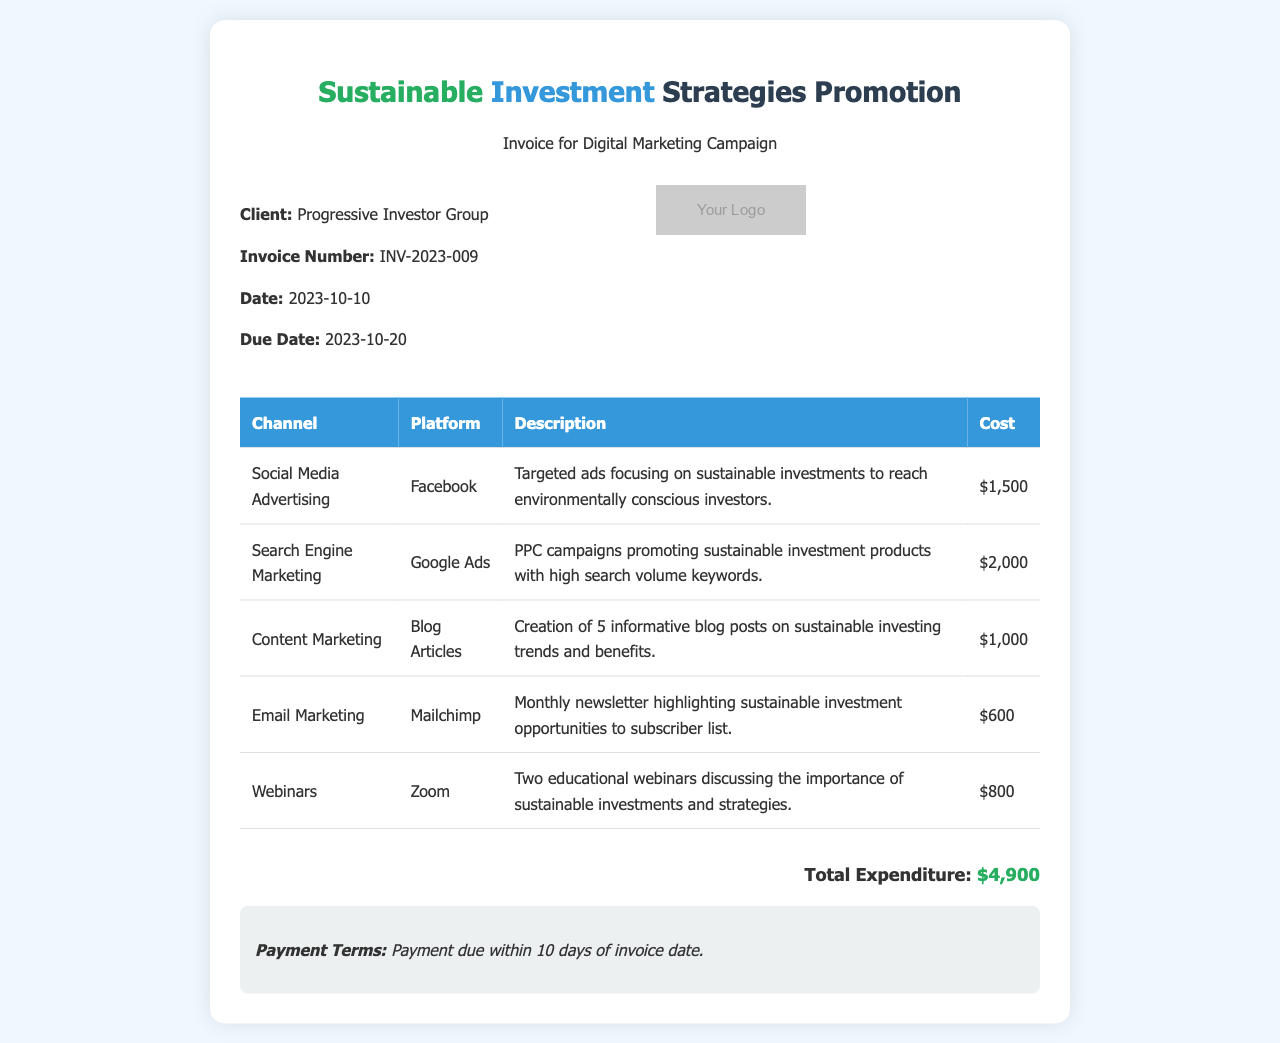What is the invoice number? The invoice number is listed in the document details section as INV-2023-009.
Answer: INV-2023-009 What is the total expenditure? The total expenditure is presented at the bottom of the document, which summarizes the total costs across all channels.
Answer: $4,900 What is the due date for the invoice? The due date is mentioned in the invoice details section, indicating when the payment must be made.
Answer: 2023-10-20 How many blog posts were created for content marketing? The description for content marketing specifies that five blog posts were created.
Answer: 5 Which platform was used for email marketing? The email marketing channel specifies that Mailchimp was the platform utilized for the campaigns.
Answer: Mailchimp What type of marketing strategy focuses on educational webinars? The document discusses webinars specifically as one of the strategies outlined for promoting sustainable investments.
Answer: Webinars What is the cost associated with Google Ads? The cost for Google Ads is clearly stated in the table, indicating the budget allocated for this specific strategy.
Answer: $2,000 What is the payment term stated in the document? The payment terms specify how long the client has to make the payment after receiving the invoice.
Answer: 10 days 